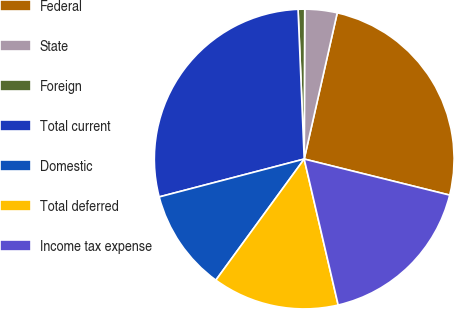Convert chart. <chart><loc_0><loc_0><loc_500><loc_500><pie_chart><fcel>Federal<fcel>State<fcel>Foreign<fcel>Total current<fcel>Domestic<fcel>Total deferred<fcel>Income tax expense<nl><fcel>25.33%<fcel>3.48%<fcel>0.71%<fcel>28.41%<fcel>10.9%<fcel>13.67%<fcel>17.49%<nl></chart> 